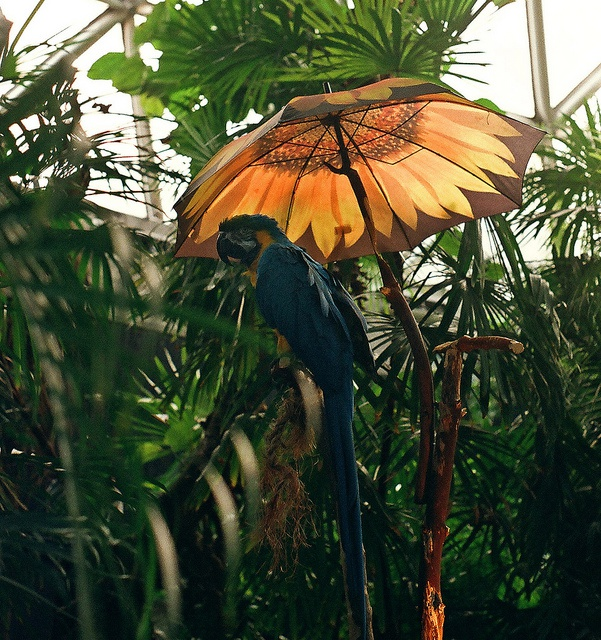Describe the objects in this image and their specific colors. I can see umbrella in white, orange, brown, and maroon tones and bird in white, black, gray, teal, and olive tones in this image. 